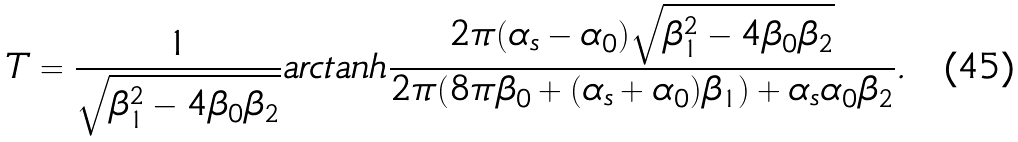Convert formula to latex. <formula><loc_0><loc_0><loc_500><loc_500>T = \frac { 1 } { \sqrt { \beta _ { 1 } ^ { 2 } - 4 \beta _ { 0 } \beta _ { 2 } } } a r c t a n h \frac { 2 \pi ( \alpha _ { s } - \alpha _ { 0 } ) \sqrt { \beta _ { 1 } ^ { 2 } - 4 \beta _ { 0 } \beta _ { 2 } } } { 2 \pi ( 8 \pi \beta _ { 0 } + ( \alpha _ { s } + \alpha _ { 0 } ) \beta _ { 1 } ) + \alpha _ { s } \alpha _ { 0 } \beta _ { 2 } } .</formula> 